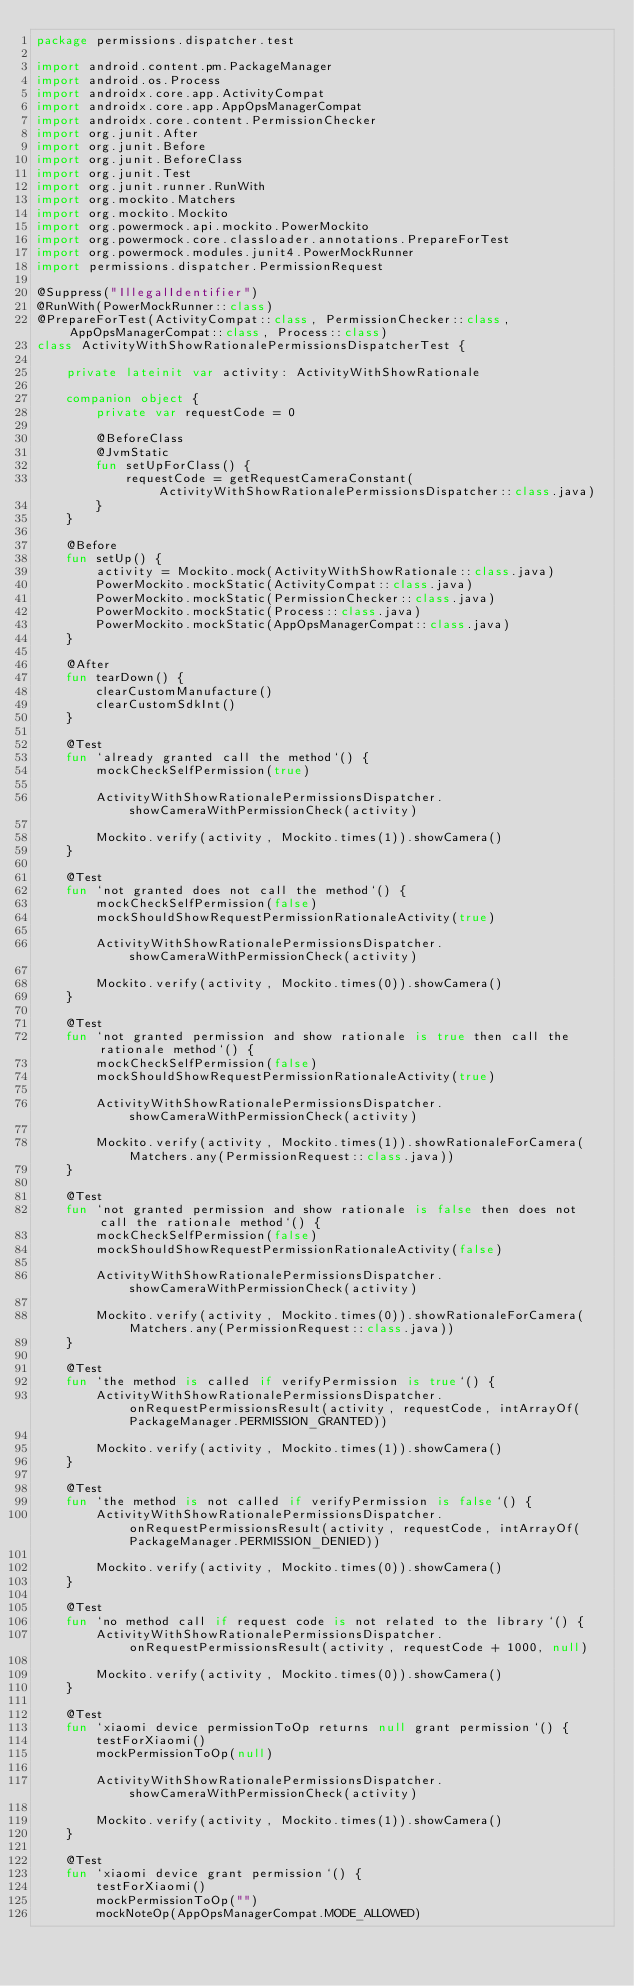Convert code to text. <code><loc_0><loc_0><loc_500><loc_500><_Kotlin_>package permissions.dispatcher.test

import android.content.pm.PackageManager
import android.os.Process
import androidx.core.app.ActivityCompat
import androidx.core.app.AppOpsManagerCompat
import androidx.core.content.PermissionChecker
import org.junit.After
import org.junit.Before
import org.junit.BeforeClass
import org.junit.Test
import org.junit.runner.RunWith
import org.mockito.Matchers
import org.mockito.Mockito
import org.powermock.api.mockito.PowerMockito
import org.powermock.core.classloader.annotations.PrepareForTest
import org.powermock.modules.junit4.PowerMockRunner
import permissions.dispatcher.PermissionRequest

@Suppress("IllegalIdentifier")
@RunWith(PowerMockRunner::class)
@PrepareForTest(ActivityCompat::class, PermissionChecker::class, AppOpsManagerCompat::class, Process::class)
class ActivityWithShowRationalePermissionsDispatcherTest {

    private lateinit var activity: ActivityWithShowRationale

    companion object {
        private var requestCode = 0

        @BeforeClass
        @JvmStatic
        fun setUpForClass() {
            requestCode = getRequestCameraConstant(ActivityWithShowRationalePermissionsDispatcher::class.java)
        }
    }

    @Before
    fun setUp() {
        activity = Mockito.mock(ActivityWithShowRationale::class.java)
        PowerMockito.mockStatic(ActivityCompat::class.java)
        PowerMockito.mockStatic(PermissionChecker::class.java)
        PowerMockito.mockStatic(Process::class.java)
        PowerMockito.mockStatic(AppOpsManagerCompat::class.java)
    }

    @After
    fun tearDown() {
        clearCustomManufacture()
        clearCustomSdkInt()
    }

    @Test
    fun `already granted call the method`() {
        mockCheckSelfPermission(true)

        ActivityWithShowRationalePermissionsDispatcher.showCameraWithPermissionCheck(activity)

        Mockito.verify(activity, Mockito.times(1)).showCamera()
    }

    @Test
    fun `not granted does not call the method`() {
        mockCheckSelfPermission(false)
        mockShouldShowRequestPermissionRationaleActivity(true)

        ActivityWithShowRationalePermissionsDispatcher.showCameraWithPermissionCheck(activity)

        Mockito.verify(activity, Mockito.times(0)).showCamera()
    }

    @Test
    fun `not granted permission and show rationale is true then call the rationale method`() {
        mockCheckSelfPermission(false)
        mockShouldShowRequestPermissionRationaleActivity(true)

        ActivityWithShowRationalePermissionsDispatcher.showCameraWithPermissionCheck(activity)

        Mockito.verify(activity, Mockito.times(1)).showRationaleForCamera(Matchers.any(PermissionRequest::class.java))
    }

    @Test
    fun `not granted permission and show rationale is false then does not call the rationale method`() {
        mockCheckSelfPermission(false)
        mockShouldShowRequestPermissionRationaleActivity(false)

        ActivityWithShowRationalePermissionsDispatcher.showCameraWithPermissionCheck(activity)

        Mockito.verify(activity, Mockito.times(0)).showRationaleForCamera(Matchers.any(PermissionRequest::class.java))
    }

    @Test
    fun `the method is called if verifyPermission is true`() {
        ActivityWithShowRationalePermissionsDispatcher.onRequestPermissionsResult(activity, requestCode, intArrayOf(PackageManager.PERMISSION_GRANTED))

        Mockito.verify(activity, Mockito.times(1)).showCamera()
    }

    @Test
    fun `the method is not called if verifyPermission is false`() {
        ActivityWithShowRationalePermissionsDispatcher.onRequestPermissionsResult(activity, requestCode, intArrayOf(PackageManager.PERMISSION_DENIED))

        Mockito.verify(activity, Mockito.times(0)).showCamera()
    }

    @Test
    fun `no method call if request code is not related to the library`() {
        ActivityWithShowRationalePermissionsDispatcher.onRequestPermissionsResult(activity, requestCode + 1000, null)

        Mockito.verify(activity, Mockito.times(0)).showCamera()
    }

    @Test
    fun `xiaomi device permissionToOp returns null grant permission`() {
        testForXiaomi()
        mockPermissionToOp(null)

        ActivityWithShowRationalePermissionsDispatcher.showCameraWithPermissionCheck(activity)

        Mockito.verify(activity, Mockito.times(1)).showCamera()
    }

    @Test
    fun `xiaomi device grant permission`() {
        testForXiaomi()
        mockPermissionToOp("")
        mockNoteOp(AppOpsManagerCompat.MODE_ALLOWED)</code> 